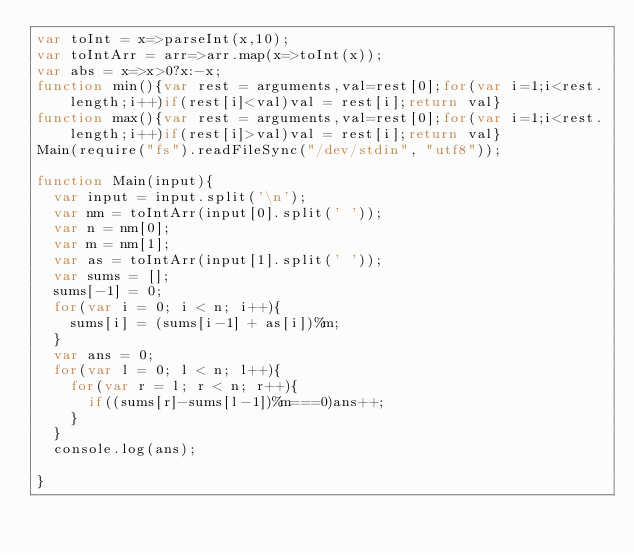<code> <loc_0><loc_0><loc_500><loc_500><_JavaScript_>var toInt = x=>parseInt(x,10);
var toIntArr = arr=>arr.map(x=>toInt(x));
var abs = x=>x>0?x:-x;
function min(){var rest = arguments,val=rest[0];for(var i=1;i<rest.length;i++)if(rest[i]<val)val = rest[i];return val}
function max(){var rest = arguments,val=rest[0];for(var i=1;i<rest.length;i++)if(rest[i]>val)val = rest[i];return val}
Main(require("fs").readFileSync("/dev/stdin", "utf8"));
 
function Main(input){
	var input = input.split('\n');
	var nm = toIntArr(input[0].split(' '));
	var n = nm[0];
	var m = nm[1];
	var as = toIntArr(input[1].split(' '));
	var sums = [];
	sums[-1] = 0;
	for(var i = 0; i < n; i++){
		sums[i] = (sums[i-1] + as[i])%m;
	}
	var ans = 0;
	for(var l = 0; l < n; l++){
		for(var r = l; r < n; r++){
			if((sums[r]-sums[l-1])%m===0)ans++;
		}
	}
	console.log(ans);

}</code> 